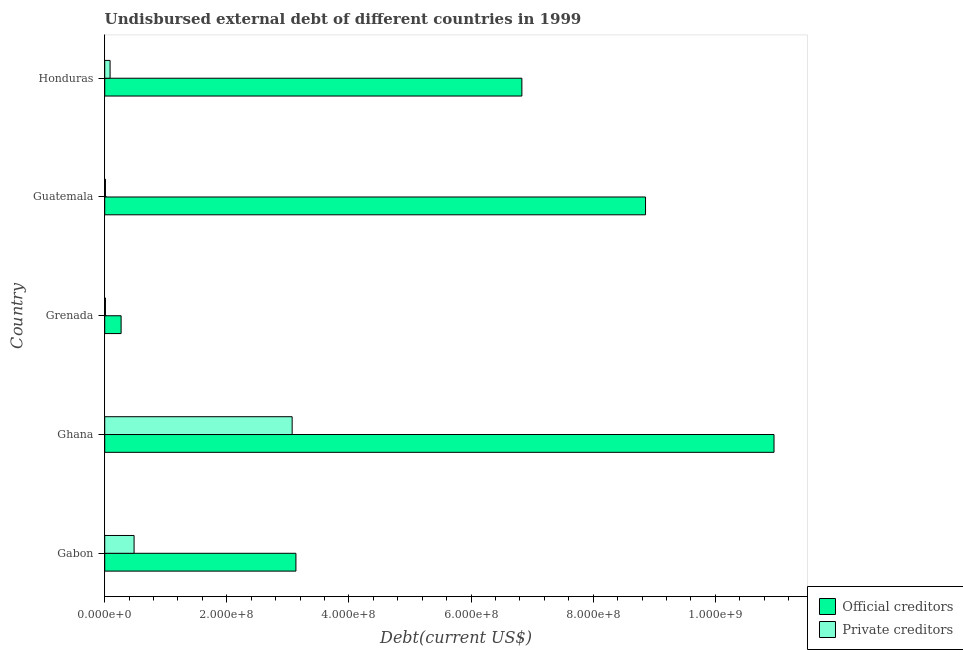How many different coloured bars are there?
Your answer should be very brief. 2. Are the number of bars on each tick of the Y-axis equal?
Offer a very short reply. Yes. What is the label of the 3rd group of bars from the top?
Offer a terse response. Grenada. In how many cases, is the number of bars for a given country not equal to the number of legend labels?
Ensure brevity in your answer.  0. What is the undisbursed external debt of official creditors in Grenada?
Your answer should be compact. 2.69e+07. Across all countries, what is the maximum undisbursed external debt of private creditors?
Provide a short and direct response. 3.07e+08. Across all countries, what is the minimum undisbursed external debt of official creditors?
Your response must be concise. 2.69e+07. In which country was the undisbursed external debt of official creditors maximum?
Offer a very short reply. Ghana. In which country was the undisbursed external debt of private creditors minimum?
Keep it short and to the point. Grenada. What is the total undisbursed external debt of official creditors in the graph?
Ensure brevity in your answer.  3.01e+09. What is the difference between the undisbursed external debt of official creditors in Gabon and that in Grenada?
Provide a succinct answer. 2.86e+08. What is the difference between the undisbursed external debt of private creditors in Guatemala and the undisbursed external debt of official creditors in Grenada?
Ensure brevity in your answer.  -2.57e+07. What is the average undisbursed external debt of official creditors per country?
Keep it short and to the point. 6.01e+08. What is the difference between the undisbursed external debt of official creditors and undisbursed external debt of private creditors in Guatemala?
Offer a terse response. 8.85e+08. In how many countries, is the undisbursed external debt of official creditors greater than 200000000 US$?
Provide a short and direct response. 4. What is the ratio of the undisbursed external debt of private creditors in Ghana to that in Grenada?
Give a very brief answer. 263.28. Is the undisbursed external debt of official creditors in Grenada less than that in Guatemala?
Your answer should be compact. Yes. What is the difference between the highest and the second highest undisbursed external debt of private creditors?
Provide a short and direct response. 2.59e+08. What is the difference between the highest and the lowest undisbursed external debt of official creditors?
Your response must be concise. 1.07e+09. What does the 2nd bar from the top in Guatemala represents?
Your answer should be very brief. Official creditors. What does the 2nd bar from the bottom in Gabon represents?
Your response must be concise. Private creditors. Are all the bars in the graph horizontal?
Provide a short and direct response. Yes. How many countries are there in the graph?
Your response must be concise. 5. What is the difference between two consecutive major ticks on the X-axis?
Offer a terse response. 2.00e+08. Does the graph contain grids?
Offer a terse response. No. How many legend labels are there?
Make the answer very short. 2. How are the legend labels stacked?
Your answer should be compact. Vertical. What is the title of the graph?
Offer a terse response. Undisbursed external debt of different countries in 1999. What is the label or title of the X-axis?
Your answer should be compact. Debt(current US$). What is the Debt(current US$) in Official creditors in Gabon?
Keep it short and to the point. 3.13e+08. What is the Debt(current US$) in Private creditors in Gabon?
Your response must be concise. 4.81e+07. What is the Debt(current US$) in Official creditors in Ghana?
Provide a succinct answer. 1.10e+09. What is the Debt(current US$) of Private creditors in Ghana?
Offer a terse response. 3.07e+08. What is the Debt(current US$) of Official creditors in Grenada?
Make the answer very short. 2.69e+07. What is the Debt(current US$) of Private creditors in Grenada?
Your answer should be very brief. 1.17e+06. What is the Debt(current US$) of Official creditors in Guatemala?
Make the answer very short. 8.86e+08. What is the Debt(current US$) of Private creditors in Guatemala?
Your answer should be very brief. 1.17e+06. What is the Debt(current US$) of Official creditors in Honduras?
Give a very brief answer. 6.83e+08. What is the Debt(current US$) of Private creditors in Honduras?
Ensure brevity in your answer.  8.78e+06. Across all countries, what is the maximum Debt(current US$) in Official creditors?
Your answer should be very brief. 1.10e+09. Across all countries, what is the maximum Debt(current US$) in Private creditors?
Ensure brevity in your answer.  3.07e+08. Across all countries, what is the minimum Debt(current US$) in Official creditors?
Provide a succinct answer. 2.69e+07. Across all countries, what is the minimum Debt(current US$) of Private creditors?
Give a very brief answer. 1.17e+06. What is the total Debt(current US$) of Official creditors in the graph?
Provide a succinct answer. 3.01e+09. What is the total Debt(current US$) of Private creditors in the graph?
Your answer should be very brief. 3.66e+08. What is the difference between the Debt(current US$) of Official creditors in Gabon and that in Ghana?
Make the answer very short. -7.83e+08. What is the difference between the Debt(current US$) of Private creditors in Gabon and that in Ghana?
Give a very brief answer. -2.59e+08. What is the difference between the Debt(current US$) of Official creditors in Gabon and that in Grenada?
Keep it short and to the point. 2.86e+08. What is the difference between the Debt(current US$) in Private creditors in Gabon and that in Grenada?
Ensure brevity in your answer.  4.69e+07. What is the difference between the Debt(current US$) of Official creditors in Gabon and that in Guatemala?
Your response must be concise. -5.73e+08. What is the difference between the Debt(current US$) in Private creditors in Gabon and that in Guatemala?
Your answer should be compact. 4.69e+07. What is the difference between the Debt(current US$) in Official creditors in Gabon and that in Honduras?
Your response must be concise. -3.70e+08. What is the difference between the Debt(current US$) of Private creditors in Gabon and that in Honduras?
Your answer should be very brief. 3.93e+07. What is the difference between the Debt(current US$) in Official creditors in Ghana and that in Grenada?
Give a very brief answer. 1.07e+09. What is the difference between the Debt(current US$) of Private creditors in Ghana and that in Grenada?
Make the answer very short. 3.06e+08. What is the difference between the Debt(current US$) of Official creditors in Ghana and that in Guatemala?
Your answer should be compact. 2.10e+08. What is the difference between the Debt(current US$) of Private creditors in Ghana and that in Guatemala?
Offer a terse response. 3.06e+08. What is the difference between the Debt(current US$) in Official creditors in Ghana and that in Honduras?
Provide a short and direct response. 4.13e+08. What is the difference between the Debt(current US$) of Private creditors in Ghana and that in Honduras?
Provide a short and direct response. 2.98e+08. What is the difference between the Debt(current US$) in Official creditors in Grenada and that in Guatemala?
Make the answer very short. -8.59e+08. What is the difference between the Debt(current US$) in Private creditors in Grenada and that in Guatemala?
Your answer should be very brief. -1000. What is the difference between the Debt(current US$) of Official creditors in Grenada and that in Honduras?
Offer a very short reply. -6.56e+08. What is the difference between the Debt(current US$) in Private creditors in Grenada and that in Honduras?
Provide a succinct answer. -7.62e+06. What is the difference between the Debt(current US$) of Official creditors in Guatemala and that in Honduras?
Offer a very short reply. 2.03e+08. What is the difference between the Debt(current US$) of Private creditors in Guatemala and that in Honduras?
Your answer should be very brief. -7.62e+06. What is the difference between the Debt(current US$) in Official creditors in Gabon and the Debt(current US$) in Private creditors in Ghana?
Provide a succinct answer. 6.18e+06. What is the difference between the Debt(current US$) of Official creditors in Gabon and the Debt(current US$) of Private creditors in Grenada?
Provide a short and direct response. 3.12e+08. What is the difference between the Debt(current US$) in Official creditors in Gabon and the Debt(current US$) in Private creditors in Guatemala?
Your response must be concise. 3.12e+08. What is the difference between the Debt(current US$) in Official creditors in Gabon and the Debt(current US$) in Private creditors in Honduras?
Your response must be concise. 3.04e+08. What is the difference between the Debt(current US$) of Official creditors in Ghana and the Debt(current US$) of Private creditors in Grenada?
Keep it short and to the point. 1.10e+09. What is the difference between the Debt(current US$) in Official creditors in Ghana and the Debt(current US$) in Private creditors in Guatemala?
Keep it short and to the point. 1.10e+09. What is the difference between the Debt(current US$) in Official creditors in Ghana and the Debt(current US$) in Private creditors in Honduras?
Keep it short and to the point. 1.09e+09. What is the difference between the Debt(current US$) of Official creditors in Grenada and the Debt(current US$) of Private creditors in Guatemala?
Your response must be concise. 2.57e+07. What is the difference between the Debt(current US$) in Official creditors in Grenada and the Debt(current US$) in Private creditors in Honduras?
Provide a short and direct response. 1.81e+07. What is the difference between the Debt(current US$) of Official creditors in Guatemala and the Debt(current US$) of Private creditors in Honduras?
Ensure brevity in your answer.  8.77e+08. What is the average Debt(current US$) of Official creditors per country?
Make the answer very short. 6.01e+08. What is the average Debt(current US$) of Private creditors per country?
Provide a short and direct response. 7.32e+07. What is the difference between the Debt(current US$) of Official creditors and Debt(current US$) of Private creditors in Gabon?
Offer a terse response. 2.65e+08. What is the difference between the Debt(current US$) of Official creditors and Debt(current US$) of Private creditors in Ghana?
Your answer should be compact. 7.89e+08. What is the difference between the Debt(current US$) in Official creditors and Debt(current US$) in Private creditors in Grenada?
Offer a very short reply. 2.57e+07. What is the difference between the Debt(current US$) in Official creditors and Debt(current US$) in Private creditors in Guatemala?
Your answer should be very brief. 8.85e+08. What is the difference between the Debt(current US$) of Official creditors and Debt(current US$) of Private creditors in Honduras?
Keep it short and to the point. 6.74e+08. What is the ratio of the Debt(current US$) of Official creditors in Gabon to that in Ghana?
Ensure brevity in your answer.  0.29. What is the ratio of the Debt(current US$) of Private creditors in Gabon to that in Ghana?
Keep it short and to the point. 0.16. What is the ratio of the Debt(current US$) of Official creditors in Gabon to that in Grenada?
Your response must be concise. 11.66. What is the ratio of the Debt(current US$) of Private creditors in Gabon to that in Grenada?
Provide a succinct answer. 41.24. What is the ratio of the Debt(current US$) of Official creditors in Gabon to that in Guatemala?
Provide a short and direct response. 0.35. What is the ratio of the Debt(current US$) in Private creditors in Gabon to that in Guatemala?
Your response must be concise. 41.2. What is the ratio of the Debt(current US$) in Official creditors in Gabon to that in Honduras?
Your answer should be very brief. 0.46. What is the ratio of the Debt(current US$) in Private creditors in Gabon to that in Honduras?
Provide a succinct answer. 5.47. What is the ratio of the Debt(current US$) of Official creditors in Ghana to that in Grenada?
Keep it short and to the point. 40.81. What is the ratio of the Debt(current US$) in Private creditors in Ghana to that in Grenada?
Your answer should be very brief. 263.28. What is the ratio of the Debt(current US$) of Official creditors in Ghana to that in Guatemala?
Provide a succinct answer. 1.24. What is the ratio of the Debt(current US$) of Private creditors in Ghana to that in Guatemala?
Provide a succinct answer. 263.06. What is the ratio of the Debt(current US$) in Official creditors in Ghana to that in Honduras?
Your response must be concise. 1.6. What is the ratio of the Debt(current US$) in Private creditors in Ghana to that in Honduras?
Your response must be concise. 34.95. What is the ratio of the Debt(current US$) in Official creditors in Grenada to that in Guatemala?
Your answer should be very brief. 0.03. What is the ratio of the Debt(current US$) of Private creditors in Grenada to that in Guatemala?
Keep it short and to the point. 1. What is the ratio of the Debt(current US$) of Official creditors in Grenada to that in Honduras?
Your response must be concise. 0.04. What is the ratio of the Debt(current US$) of Private creditors in Grenada to that in Honduras?
Give a very brief answer. 0.13. What is the ratio of the Debt(current US$) of Official creditors in Guatemala to that in Honduras?
Make the answer very short. 1.3. What is the ratio of the Debt(current US$) in Private creditors in Guatemala to that in Honduras?
Your response must be concise. 0.13. What is the difference between the highest and the second highest Debt(current US$) in Official creditors?
Provide a short and direct response. 2.10e+08. What is the difference between the highest and the second highest Debt(current US$) in Private creditors?
Provide a succinct answer. 2.59e+08. What is the difference between the highest and the lowest Debt(current US$) in Official creditors?
Provide a succinct answer. 1.07e+09. What is the difference between the highest and the lowest Debt(current US$) in Private creditors?
Offer a terse response. 3.06e+08. 